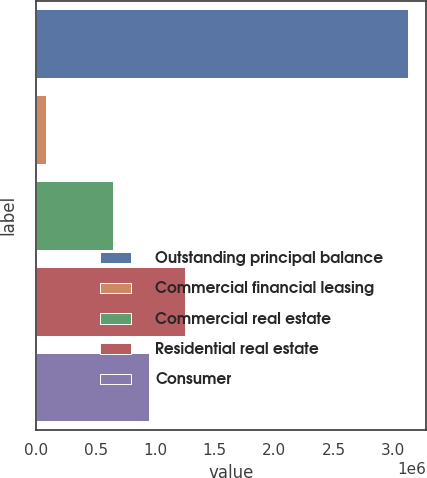Convert chart. <chart><loc_0><loc_0><loc_500><loc_500><bar_chart><fcel>Outstanding principal balance<fcel>Commercial financial leasing<fcel>Commercial real estate<fcel>Residential real estate<fcel>Consumer<nl><fcel>3.12294e+06<fcel>78847<fcel>644284<fcel>1.2531e+06<fcel>948693<nl></chart> 